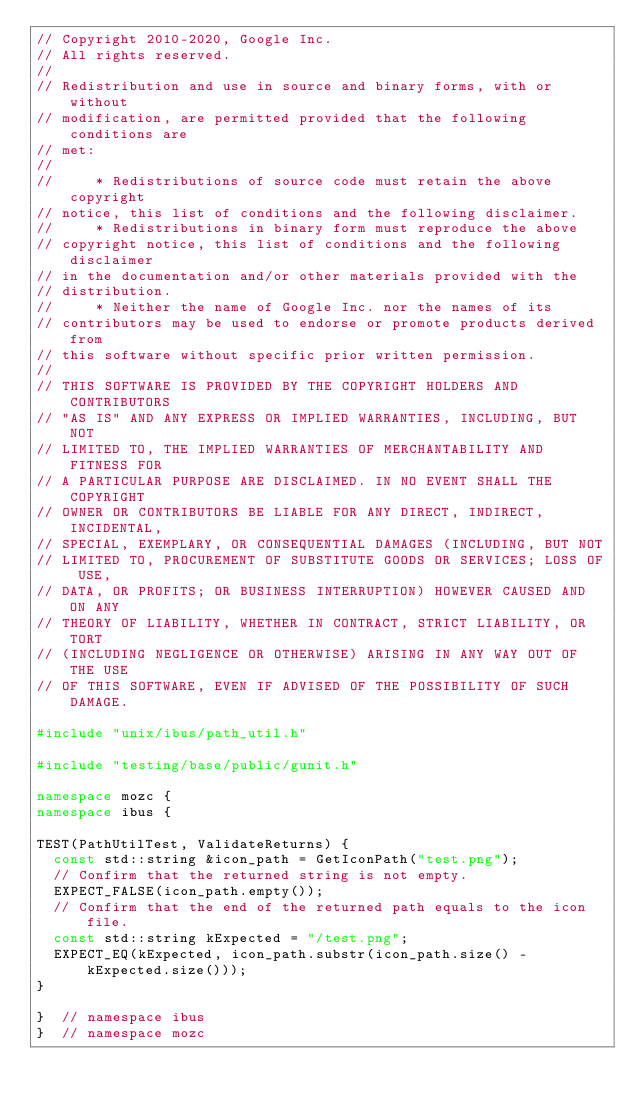<code> <loc_0><loc_0><loc_500><loc_500><_C++_>// Copyright 2010-2020, Google Inc.
// All rights reserved.
//
// Redistribution and use in source and binary forms, with or without
// modification, are permitted provided that the following conditions are
// met:
//
//     * Redistributions of source code must retain the above copyright
// notice, this list of conditions and the following disclaimer.
//     * Redistributions in binary form must reproduce the above
// copyright notice, this list of conditions and the following disclaimer
// in the documentation and/or other materials provided with the
// distribution.
//     * Neither the name of Google Inc. nor the names of its
// contributors may be used to endorse or promote products derived from
// this software without specific prior written permission.
//
// THIS SOFTWARE IS PROVIDED BY THE COPYRIGHT HOLDERS AND CONTRIBUTORS
// "AS IS" AND ANY EXPRESS OR IMPLIED WARRANTIES, INCLUDING, BUT NOT
// LIMITED TO, THE IMPLIED WARRANTIES OF MERCHANTABILITY AND FITNESS FOR
// A PARTICULAR PURPOSE ARE DISCLAIMED. IN NO EVENT SHALL THE COPYRIGHT
// OWNER OR CONTRIBUTORS BE LIABLE FOR ANY DIRECT, INDIRECT, INCIDENTAL,
// SPECIAL, EXEMPLARY, OR CONSEQUENTIAL DAMAGES (INCLUDING, BUT NOT
// LIMITED TO, PROCUREMENT OF SUBSTITUTE GOODS OR SERVICES; LOSS OF USE,
// DATA, OR PROFITS; OR BUSINESS INTERRUPTION) HOWEVER CAUSED AND ON ANY
// THEORY OF LIABILITY, WHETHER IN CONTRACT, STRICT LIABILITY, OR TORT
// (INCLUDING NEGLIGENCE OR OTHERWISE) ARISING IN ANY WAY OUT OF THE USE
// OF THIS SOFTWARE, EVEN IF ADVISED OF THE POSSIBILITY OF SUCH DAMAGE.

#include "unix/ibus/path_util.h"

#include "testing/base/public/gunit.h"

namespace mozc {
namespace ibus {

TEST(PathUtilTest, ValidateReturns) {
  const std::string &icon_path = GetIconPath("test.png");
  // Confirm that the returned string is not empty.
  EXPECT_FALSE(icon_path.empty());
  // Confirm that the end of the returned path equals to the icon file.
  const std::string kExpected = "/test.png";
  EXPECT_EQ(kExpected, icon_path.substr(icon_path.size() - kExpected.size()));
}

}  // namespace ibus
}  // namespace mozc
</code> 